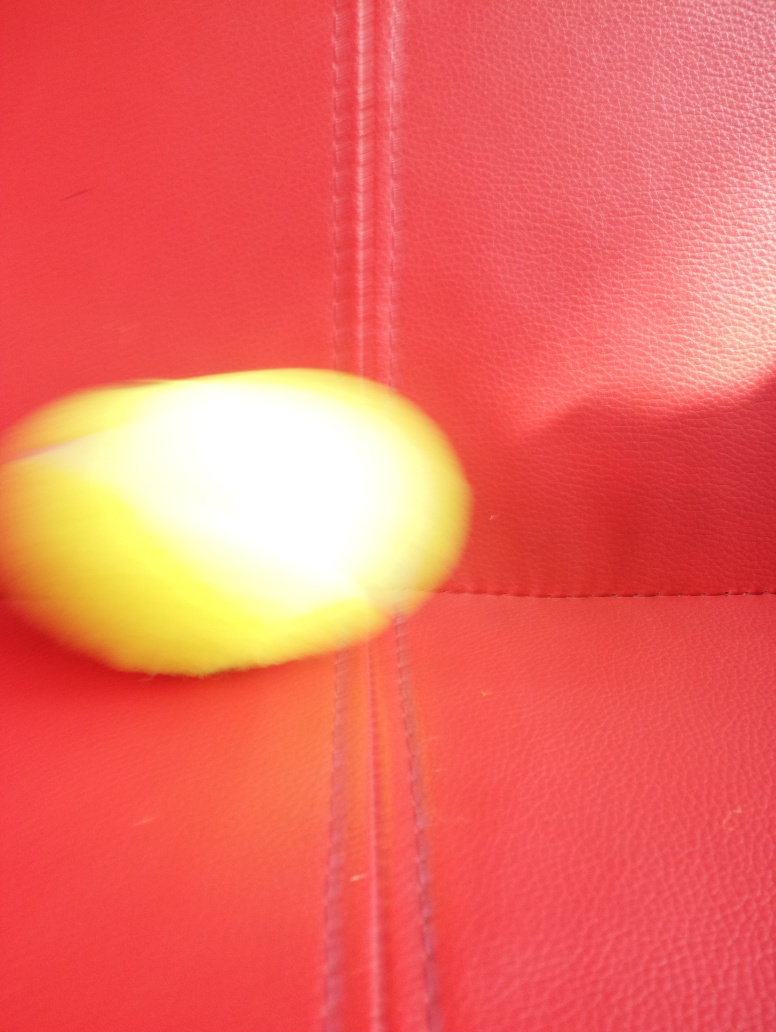Could you guess the time of day the photo was taken? Determining the exact time of day from this image is challenging due to the lack of environmental context and natural lighting indicators. It could have been taken indoors under artificial lighting, making any estimation of the time of day speculative at best. 